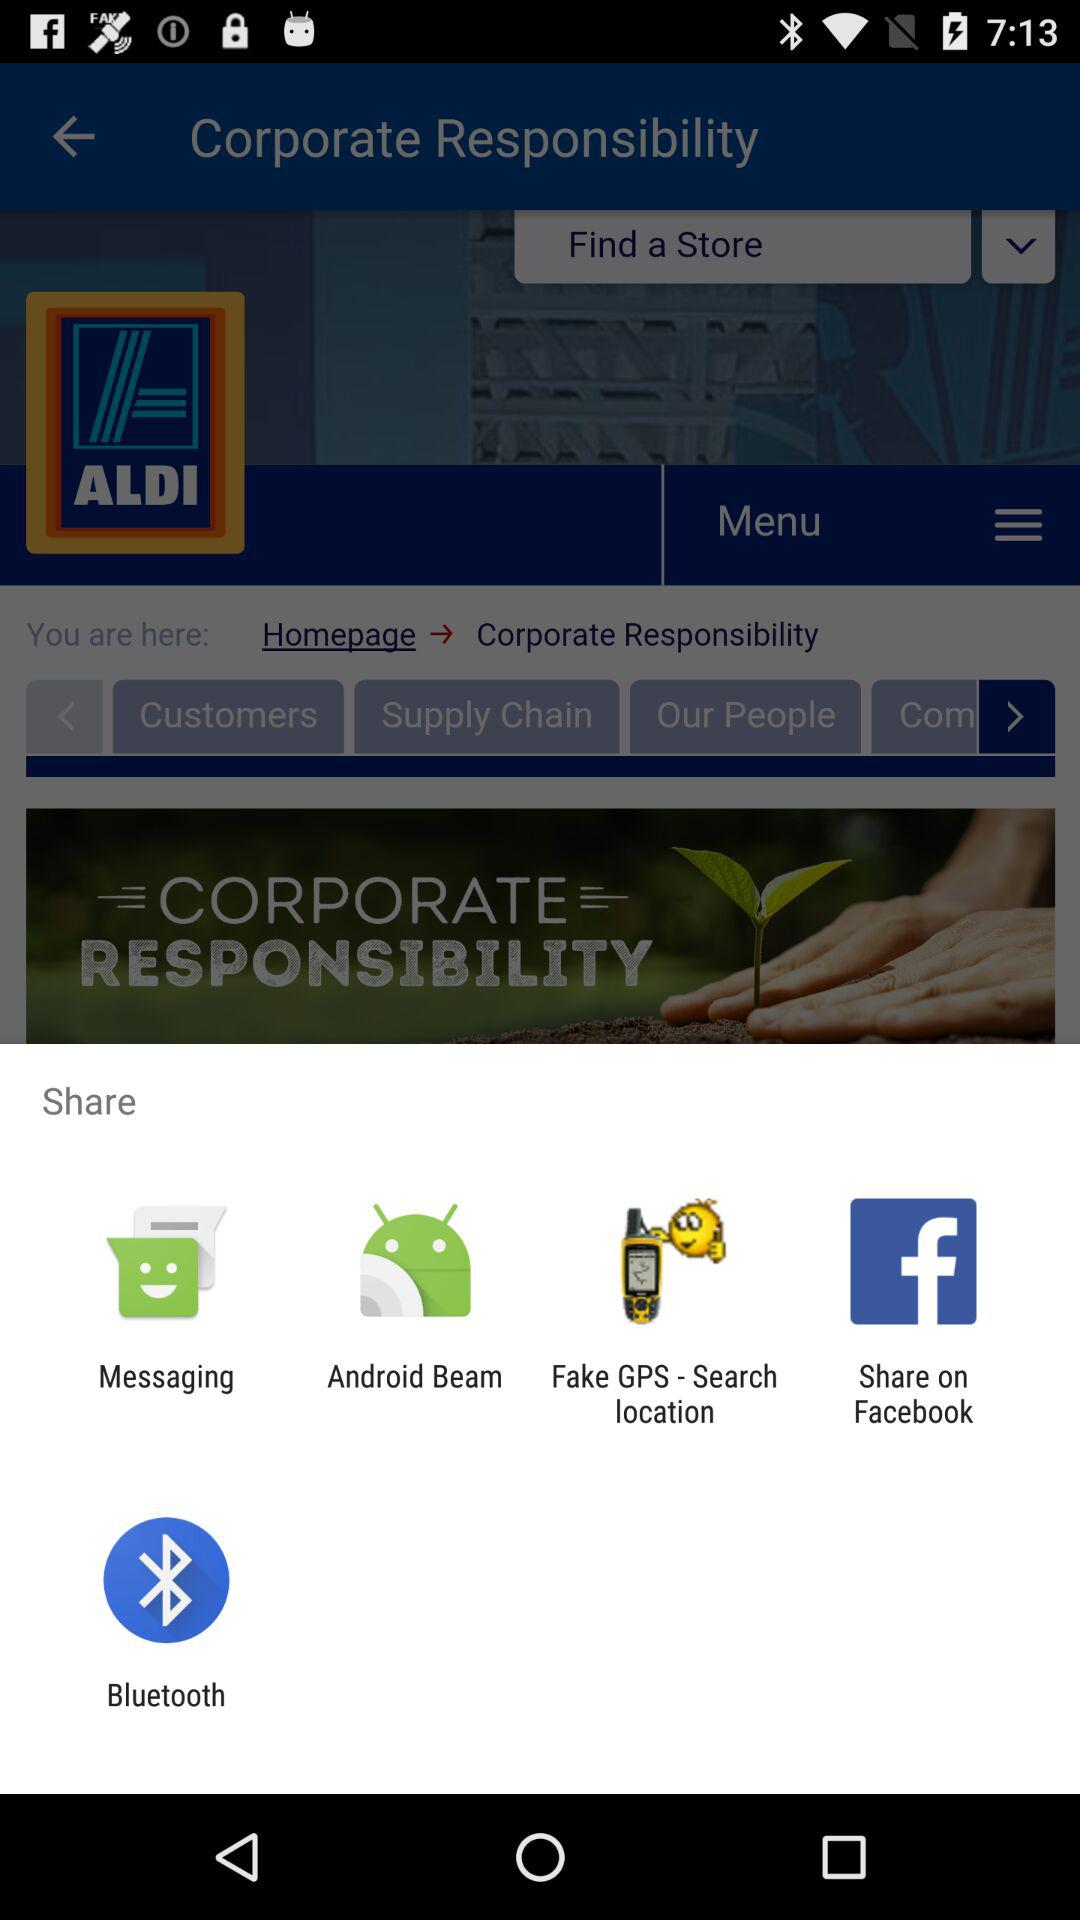Where is the nearest store?
When the provided information is insufficient, respond with <no answer>. <no answer> 